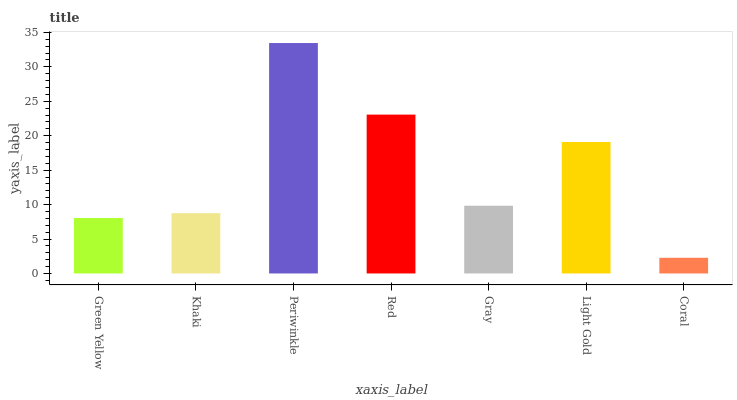Is Khaki the minimum?
Answer yes or no. No. Is Khaki the maximum?
Answer yes or no. No. Is Khaki greater than Green Yellow?
Answer yes or no. Yes. Is Green Yellow less than Khaki?
Answer yes or no. Yes. Is Green Yellow greater than Khaki?
Answer yes or no. No. Is Khaki less than Green Yellow?
Answer yes or no. No. Is Gray the high median?
Answer yes or no. Yes. Is Gray the low median?
Answer yes or no. Yes. Is Green Yellow the high median?
Answer yes or no. No. Is Periwinkle the low median?
Answer yes or no. No. 